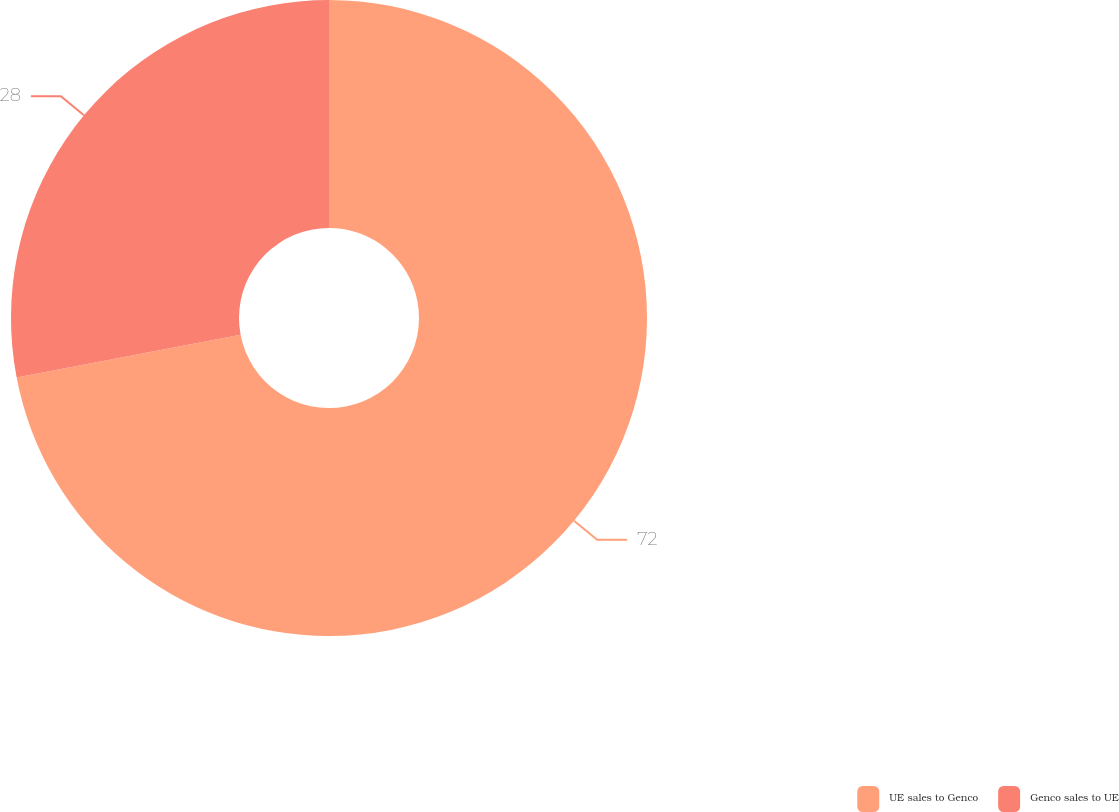Convert chart. <chart><loc_0><loc_0><loc_500><loc_500><pie_chart><fcel>UE sales to Genco<fcel>Genco sales to UE<nl><fcel>72.0%<fcel>28.0%<nl></chart> 